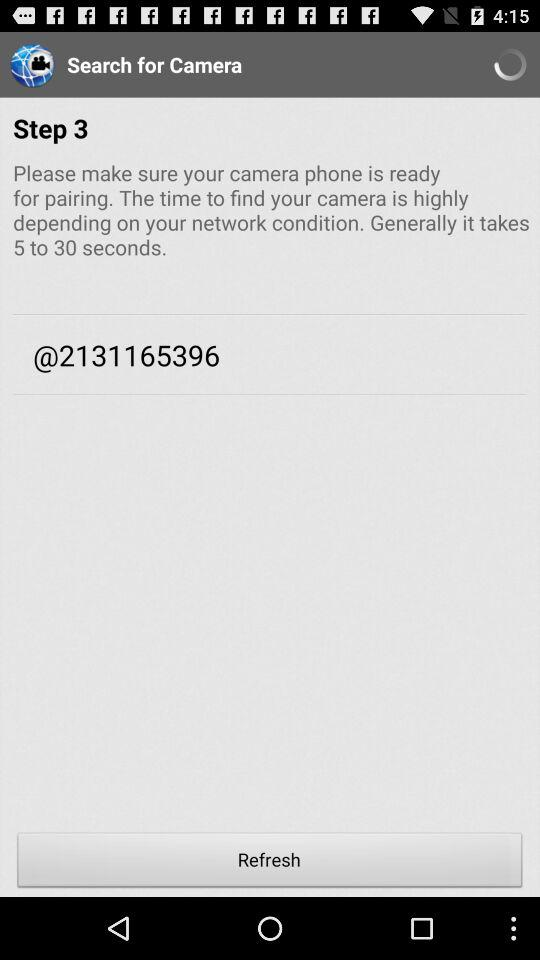How much time does it take to find the camera? It takes 5 to 30 seconds to find the camera. 